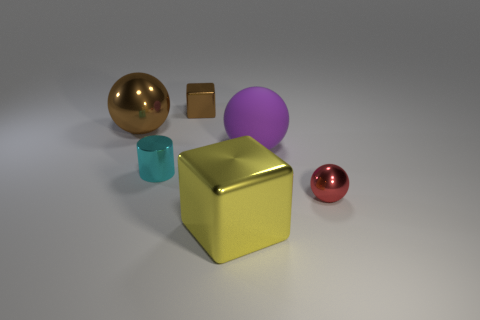Subtract all metallic balls. How many balls are left? 1 Add 1 big purple shiny things. How many objects exist? 7 Subtract all red spheres. How many spheres are left? 2 Subtract all cylinders. How many objects are left? 5 Subtract 2 balls. How many balls are left? 1 Subtract 0 purple cylinders. How many objects are left? 6 Subtract all purple blocks. Subtract all blue cylinders. How many blocks are left? 2 Subtract all small red matte balls. Subtract all small metallic cylinders. How many objects are left? 5 Add 2 purple things. How many purple things are left? 3 Add 1 small cyan blocks. How many small cyan blocks exist? 1 